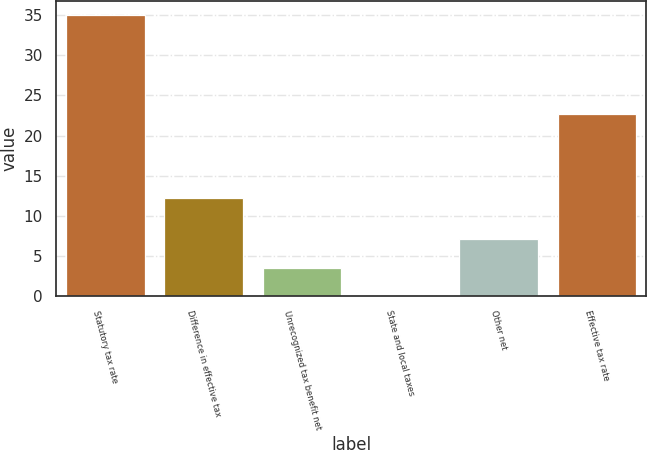Convert chart to OTSL. <chart><loc_0><loc_0><loc_500><loc_500><bar_chart><fcel>Statutory tax rate<fcel>Difference in effective tax<fcel>Unrecognized tax benefit net<fcel>State and local taxes<fcel>Other net<fcel>Effective tax rate<nl><fcel>35<fcel>12.2<fcel>3.59<fcel>0.1<fcel>7.08<fcel>22.7<nl></chart> 